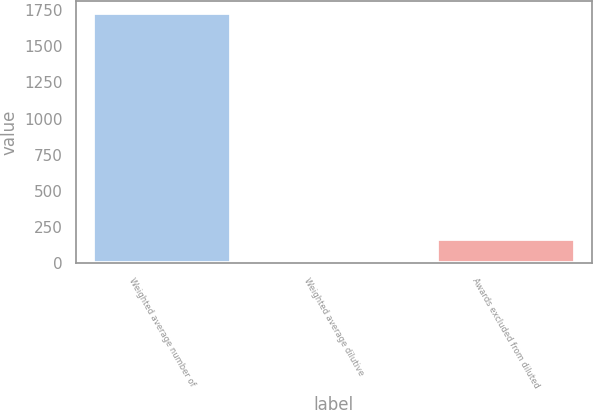<chart> <loc_0><loc_0><loc_500><loc_500><bar_chart><fcel>Weighted average number of<fcel>Weighted average dilutive<fcel>Awards excluded from diluted<nl><fcel>1724.8<fcel>10<fcel>166.8<nl></chart> 